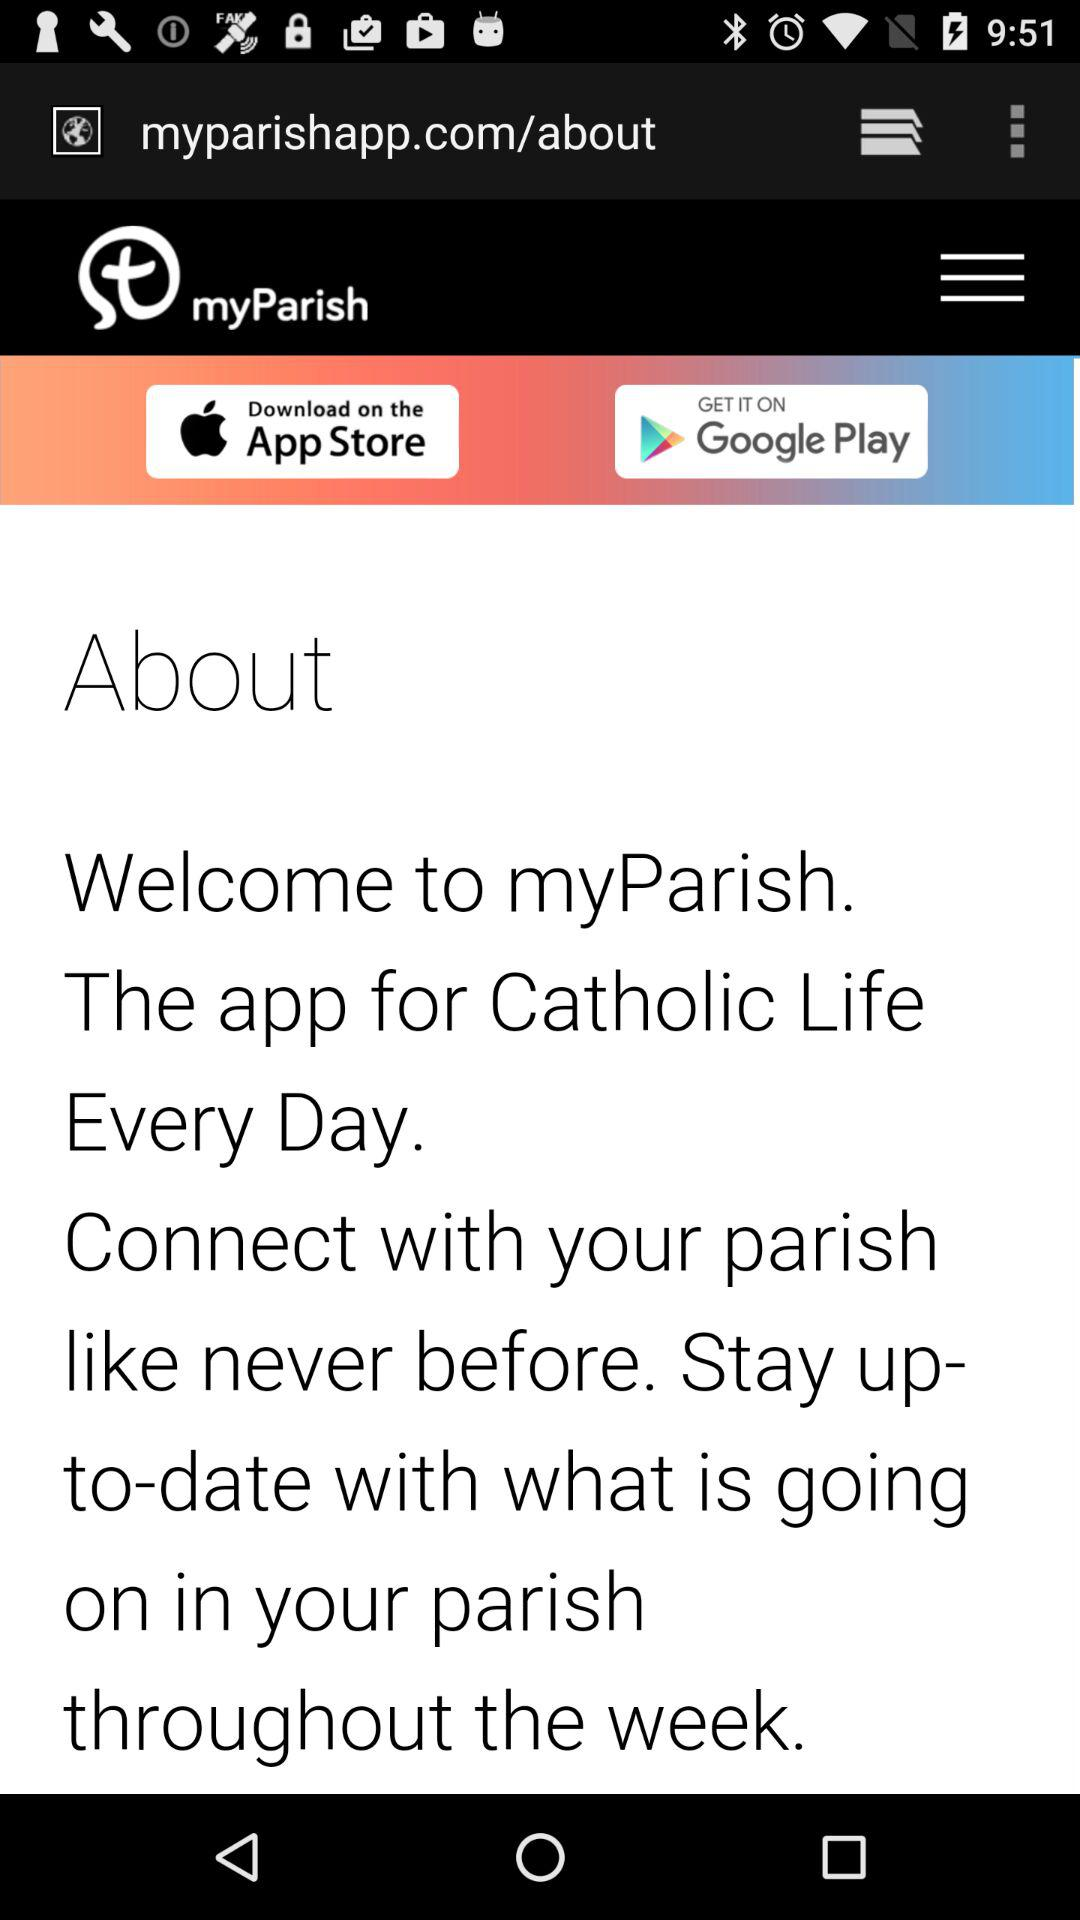What is the application used for?
When the provided information is insufficient, respond with <no answer>. <no answer> 